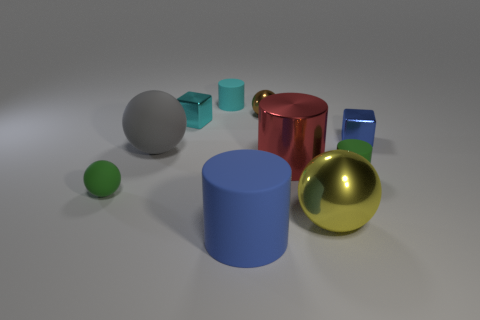Can you tell me more about the colors of the objects in the image? Certainly! The image showcases a collection of objects with varying colors. There's a green sphere, a blue cylinder, and a smaller blue cylinder, along with a red cup, a gold and a gray sphere, and a metallic blue rectangular prism. These objects are arranged on a light surface against a neutral background. 